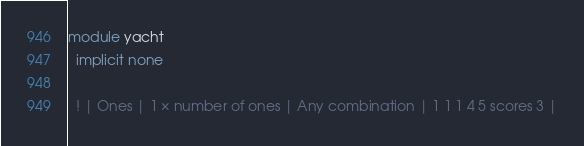<code> <loc_0><loc_0><loc_500><loc_500><_FORTRAN_>
module yacht
  implicit none

  ! | Ones | 1 × number of ones | Any combination	| 1 1 1 4 5 scores 3 |</code> 